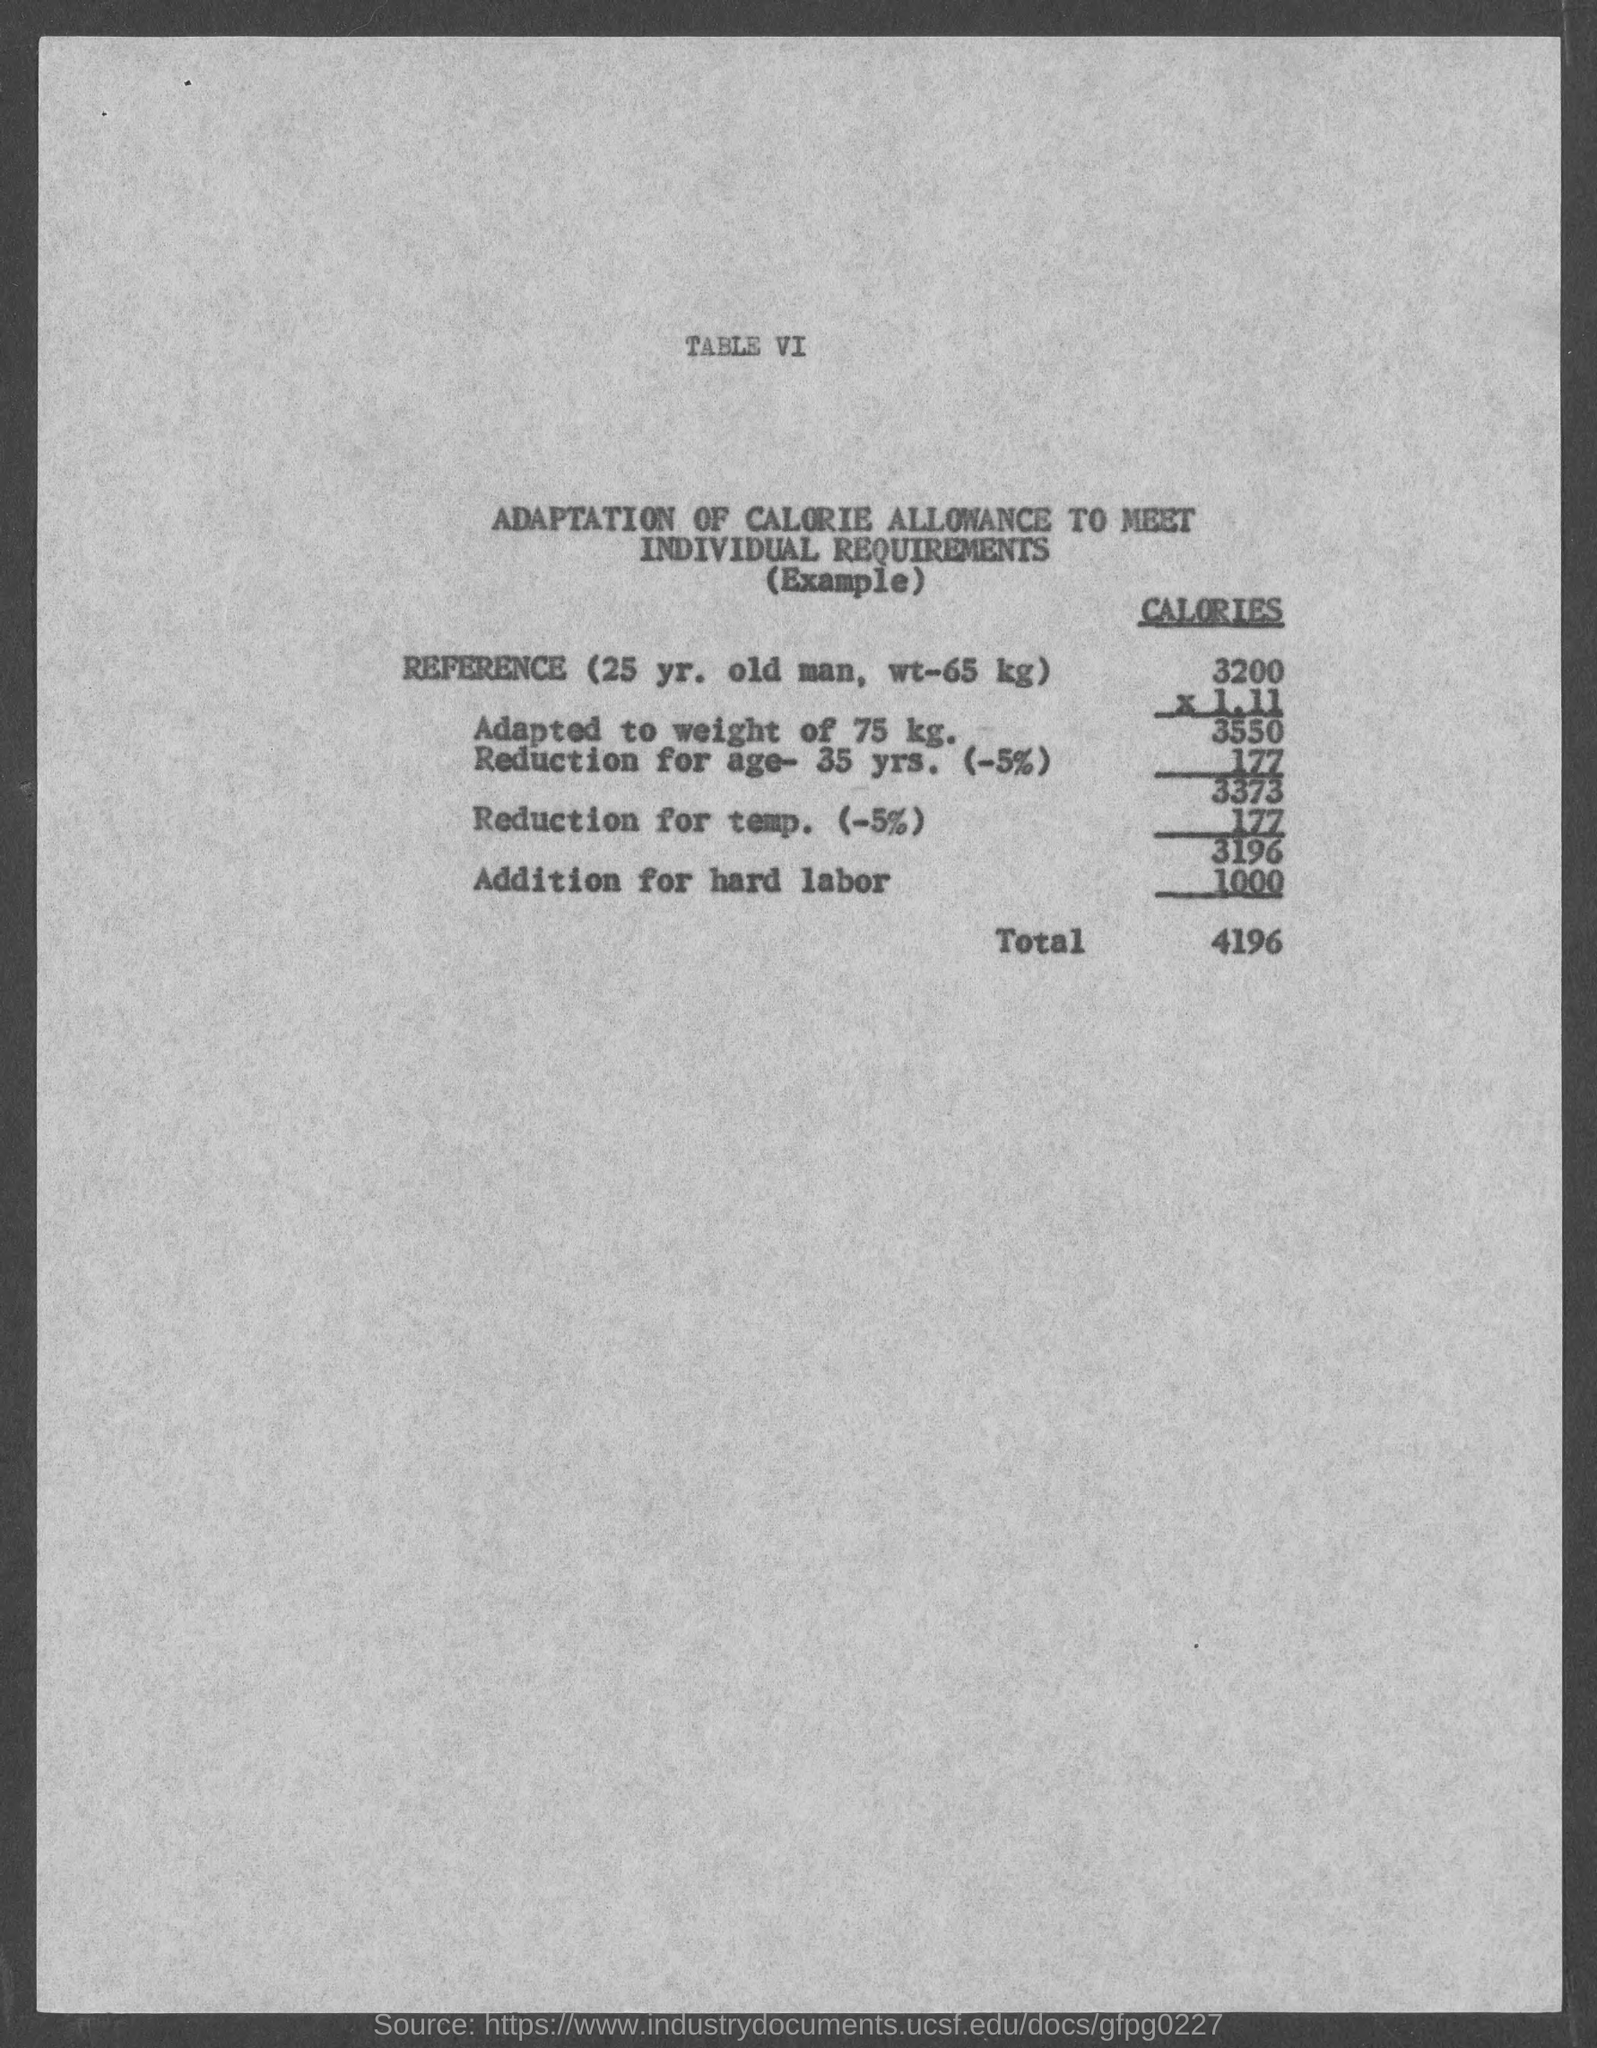What is the age of the reference person?
Offer a very short reply. 25 yr. What is the heading of the Table ?
Your response must be concise. ADAPTATION OF CALORIE ALLOWANCE TO MEET INDIVIDUAL REQUIREMENTS. How much is the Total calories ?
Keep it short and to the point. 4196. 